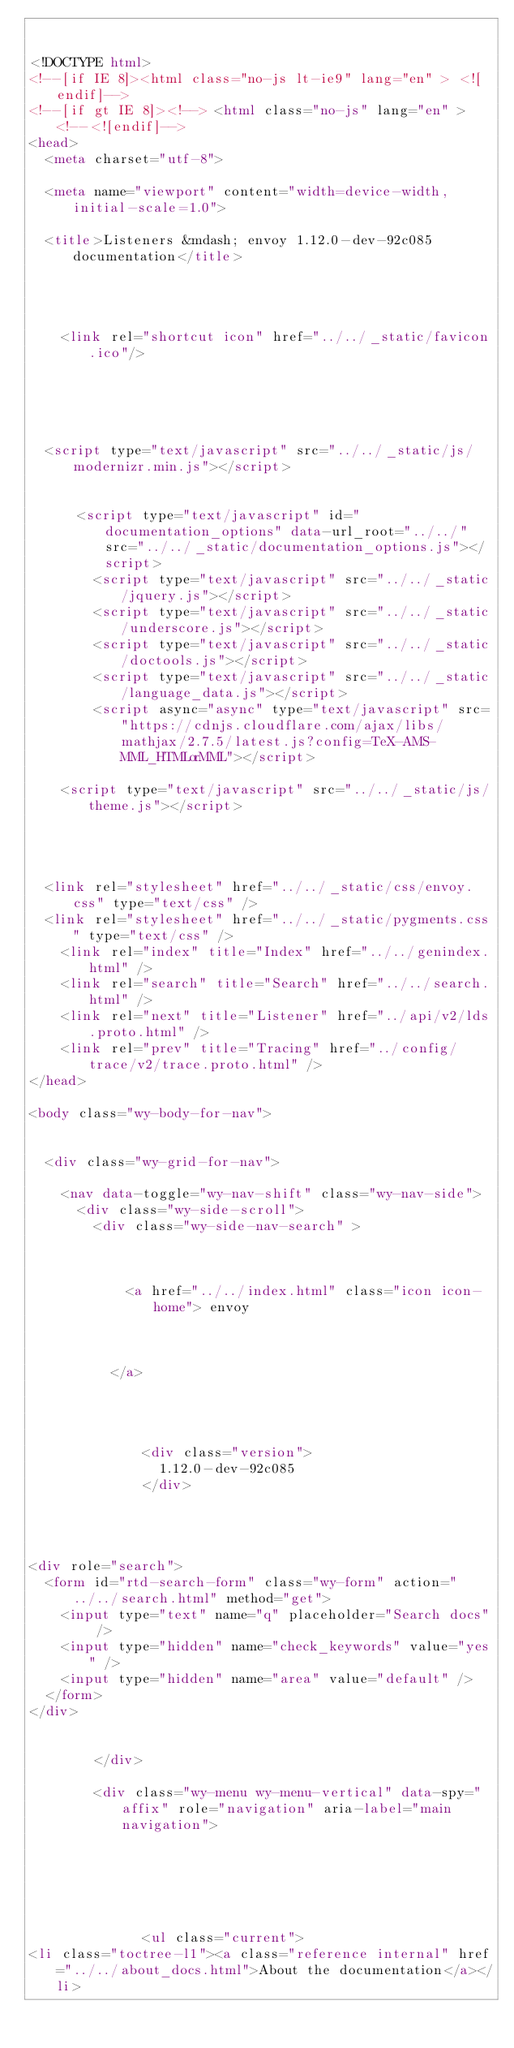Convert code to text. <code><loc_0><loc_0><loc_500><loc_500><_HTML_>

<!DOCTYPE html>
<!--[if IE 8]><html class="no-js lt-ie9" lang="en" > <![endif]-->
<!--[if gt IE 8]><!--> <html class="no-js" lang="en" > <!--<![endif]-->
<head>
  <meta charset="utf-8">
  
  <meta name="viewport" content="width=device-width, initial-scale=1.0">
  
  <title>Listeners &mdash; envoy 1.12.0-dev-92c085 documentation</title>
  

  
  
    <link rel="shortcut icon" href="../../_static/favicon.ico"/>
  
  
  

  
  <script type="text/javascript" src="../../_static/js/modernizr.min.js"></script>
  
    
      <script type="text/javascript" id="documentation_options" data-url_root="../../" src="../../_static/documentation_options.js"></script>
        <script type="text/javascript" src="../../_static/jquery.js"></script>
        <script type="text/javascript" src="../../_static/underscore.js"></script>
        <script type="text/javascript" src="../../_static/doctools.js"></script>
        <script type="text/javascript" src="../../_static/language_data.js"></script>
        <script async="async" type="text/javascript" src="https://cdnjs.cloudflare.com/ajax/libs/mathjax/2.7.5/latest.js?config=TeX-AMS-MML_HTMLorMML"></script>
    
    <script type="text/javascript" src="../../_static/js/theme.js"></script>

    

  
  <link rel="stylesheet" href="../../_static/css/envoy.css" type="text/css" />
  <link rel="stylesheet" href="../../_static/pygments.css" type="text/css" />
    <link rel="index" title="Index" href="../../genindex.html" />
    <link rel="search" title="Search" href="../../search.html" />
    <link rel="next" title="Listener" href="../api/v2/lds.proto.html" />
    <link rel="prev" title="Tracing" href="../config/trace/v2/trace.proto.html" /> 
</head>

<body class="wy-body-for-nav">

   
  <div class="wy-grid-for-nav">
    
    <nav data-toggle="wy-nav-shift" class="wy-nav-side">
      <div class="wy-side-scroll">
        <div class="wy-side-nav-search" >
          

          
            <a href="../../index.html" class="icon icon-home"> envoy
          

          
          </a>

          
            
            
              <div class="version">
                1.12.0-dev-92c085
              </div>
            
          

          
<div role="search">
  <form id="rtd-search-form" class="wy-form" action="../../search.html" method="get">
    <input type="text" name="q" placeholder="Search docs" />
    <input type="hidden" name="check_keywords" value="yes" />
    <input type="hidden" name="area" value="default" />
  </form>
</div>

          
        </div>

        <div class="wy-menu wy-menu-vertical" data-spy="affix" role="navigation" aria-label="main navigation">
          
            
            
              
            
            
              <ul class="current">
<li class="toctree-l1"><a class="reference internal" href="../../about_docs.html">About the documentation</a></li></code> 